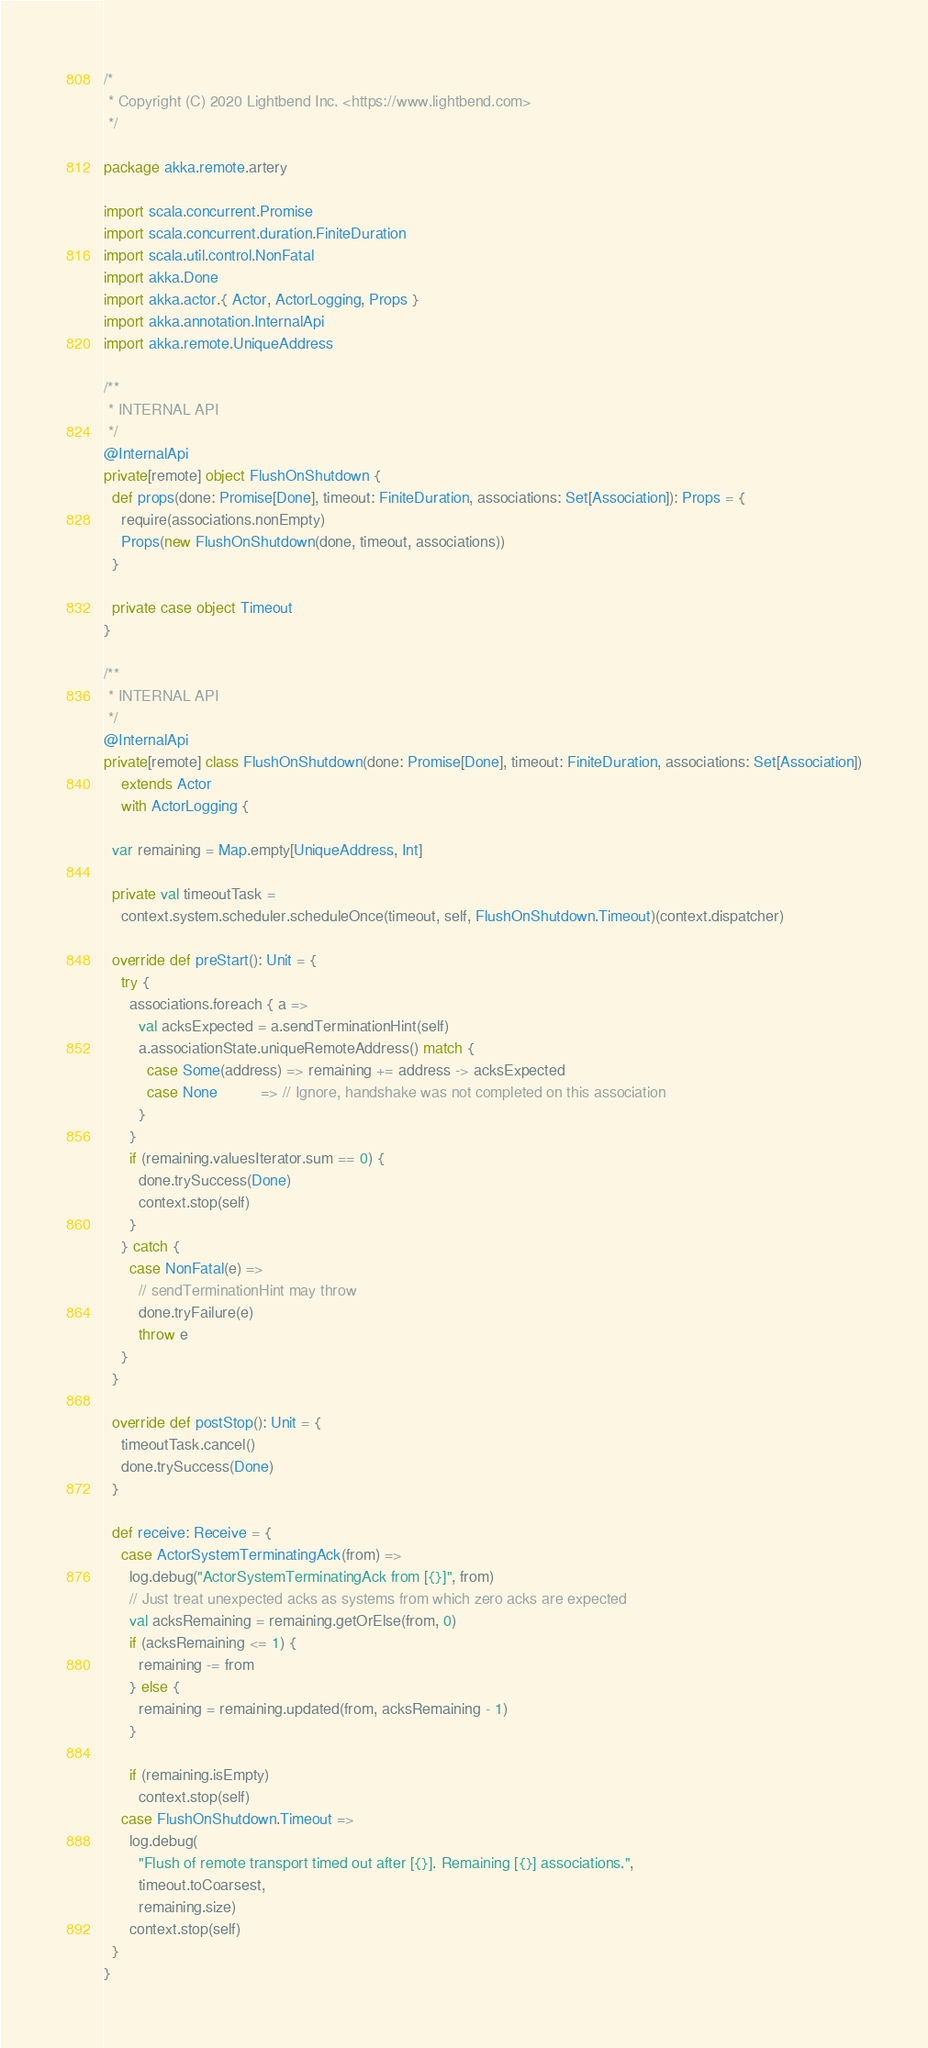Convert code to text. <code><loc_0><loc_0><loc_500><loc_500><_Scala_>/*
 * Copyright (C) 2020 Lightbend Inc. <https://www.lightbend.com>
 */

package akka.remote.artery

import scala.concurrent.Promise
import scala.concurrent.duration.FiniteDuration
import scala.util.control.NonFatal
import akka.Done
import akka.actor.{ Actor, ActorLogging, Props }
import akka.annotation.InternalApi
import akka.remote.UniqueAddress

/**
 * INTERNAL API
 */
@InternalApi
private[remote] object FlushOnShutdown {
  def props(done: Promise[Done], timeout: FiniteDuration, associations: Set[Association]): Props = {
    require(associations.nonEmpty)
    Props(new FlushOnShutdown(done, timeout, associations))
  }

  private case object Timeout
}

/**
 * INTERNAL API
 */
@InternalApi
private[remote] class FlushOnShutdown(done: Promise[Done], timeout: FiniteDuration, associations: Set[Association])
    extends Actor
    with ActorLogging {

  var remaining = Map.empty[UniqueAddress, Int]

  private val timeoutTask =
    context.system.scheduler.scheduleOnce(timeout, self, FlushOnShutdown.Timeout)(context.dispatcher)

  override def preStart(): Unit = {
    try {
      associations.foreach { a =>
        val acksExpected = a.sendTerminationHint(self)
        a.associationState.uniqueRemoteAddress() match {
          case Some(address) => remaining += address -> acksExpected
          case None          => // Ignore, handshake was not completed on this association
        }
      }
      if (remaining.valuesIterator.sum == 0) {
        done.trySuccess(Done)
        context.stop(self)
      }
    } catch {
      case NonFatal(e) =>
        // sendTerminationHint may throw
        done.tryFailure(e)
        throw e
    }
  }

  override def postStop(): Unit = {
    timeoutTask.cancel()
    done.trySuccess(Done)
  }

  def receive: Receive = {
    case ActorSystemTerminatingAck(from) =>
      log.debug("ActorSystemTerminatingAck from [{}]", from)
      // Just treat unexpected acks as systems from which zero acks are expected
      val acksRemaining = remaining.getOrElse(from, 0)
      if (acksRemaining <= 1) {
        remaining -= from
      } else {
        remaining = remaining.updated(from, acksRemaining - 1)
      }

      if (remaining.isEmpty)
        context.stop(self)
    case FlushOnShutdown.Timeout =>
      log.debug(
        "Flush of remote transport timed out after [{}]. Remaining [{}] associations.",
        timeout.toCoarsest,
        remaining.size)
      context.stop(self)
  }
}
</code> 